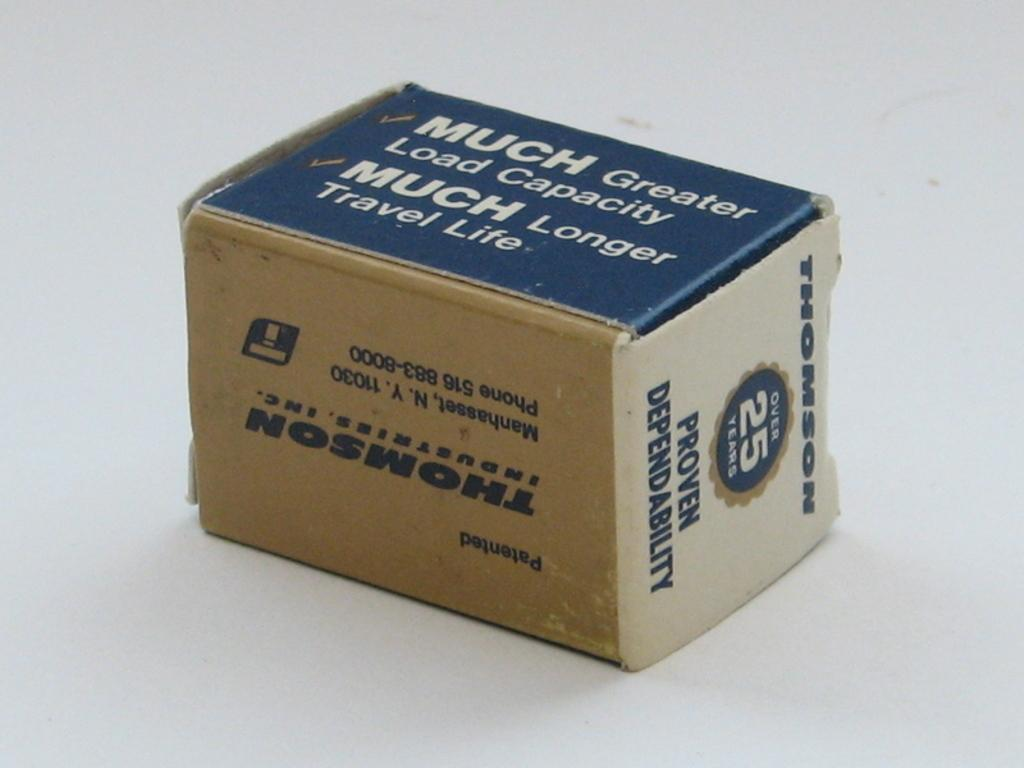<image>
Present a compact description of the photo's key features. Thompson Industries swears that its products have proven dependability. 